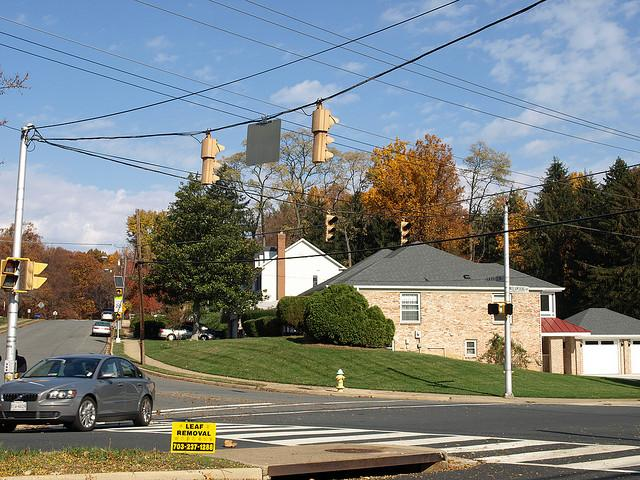What kind of trash can the company advertising on yellow sign help with?

Choices:
A) construction
B) appliance
C) recyclable
D) leaf leaf 